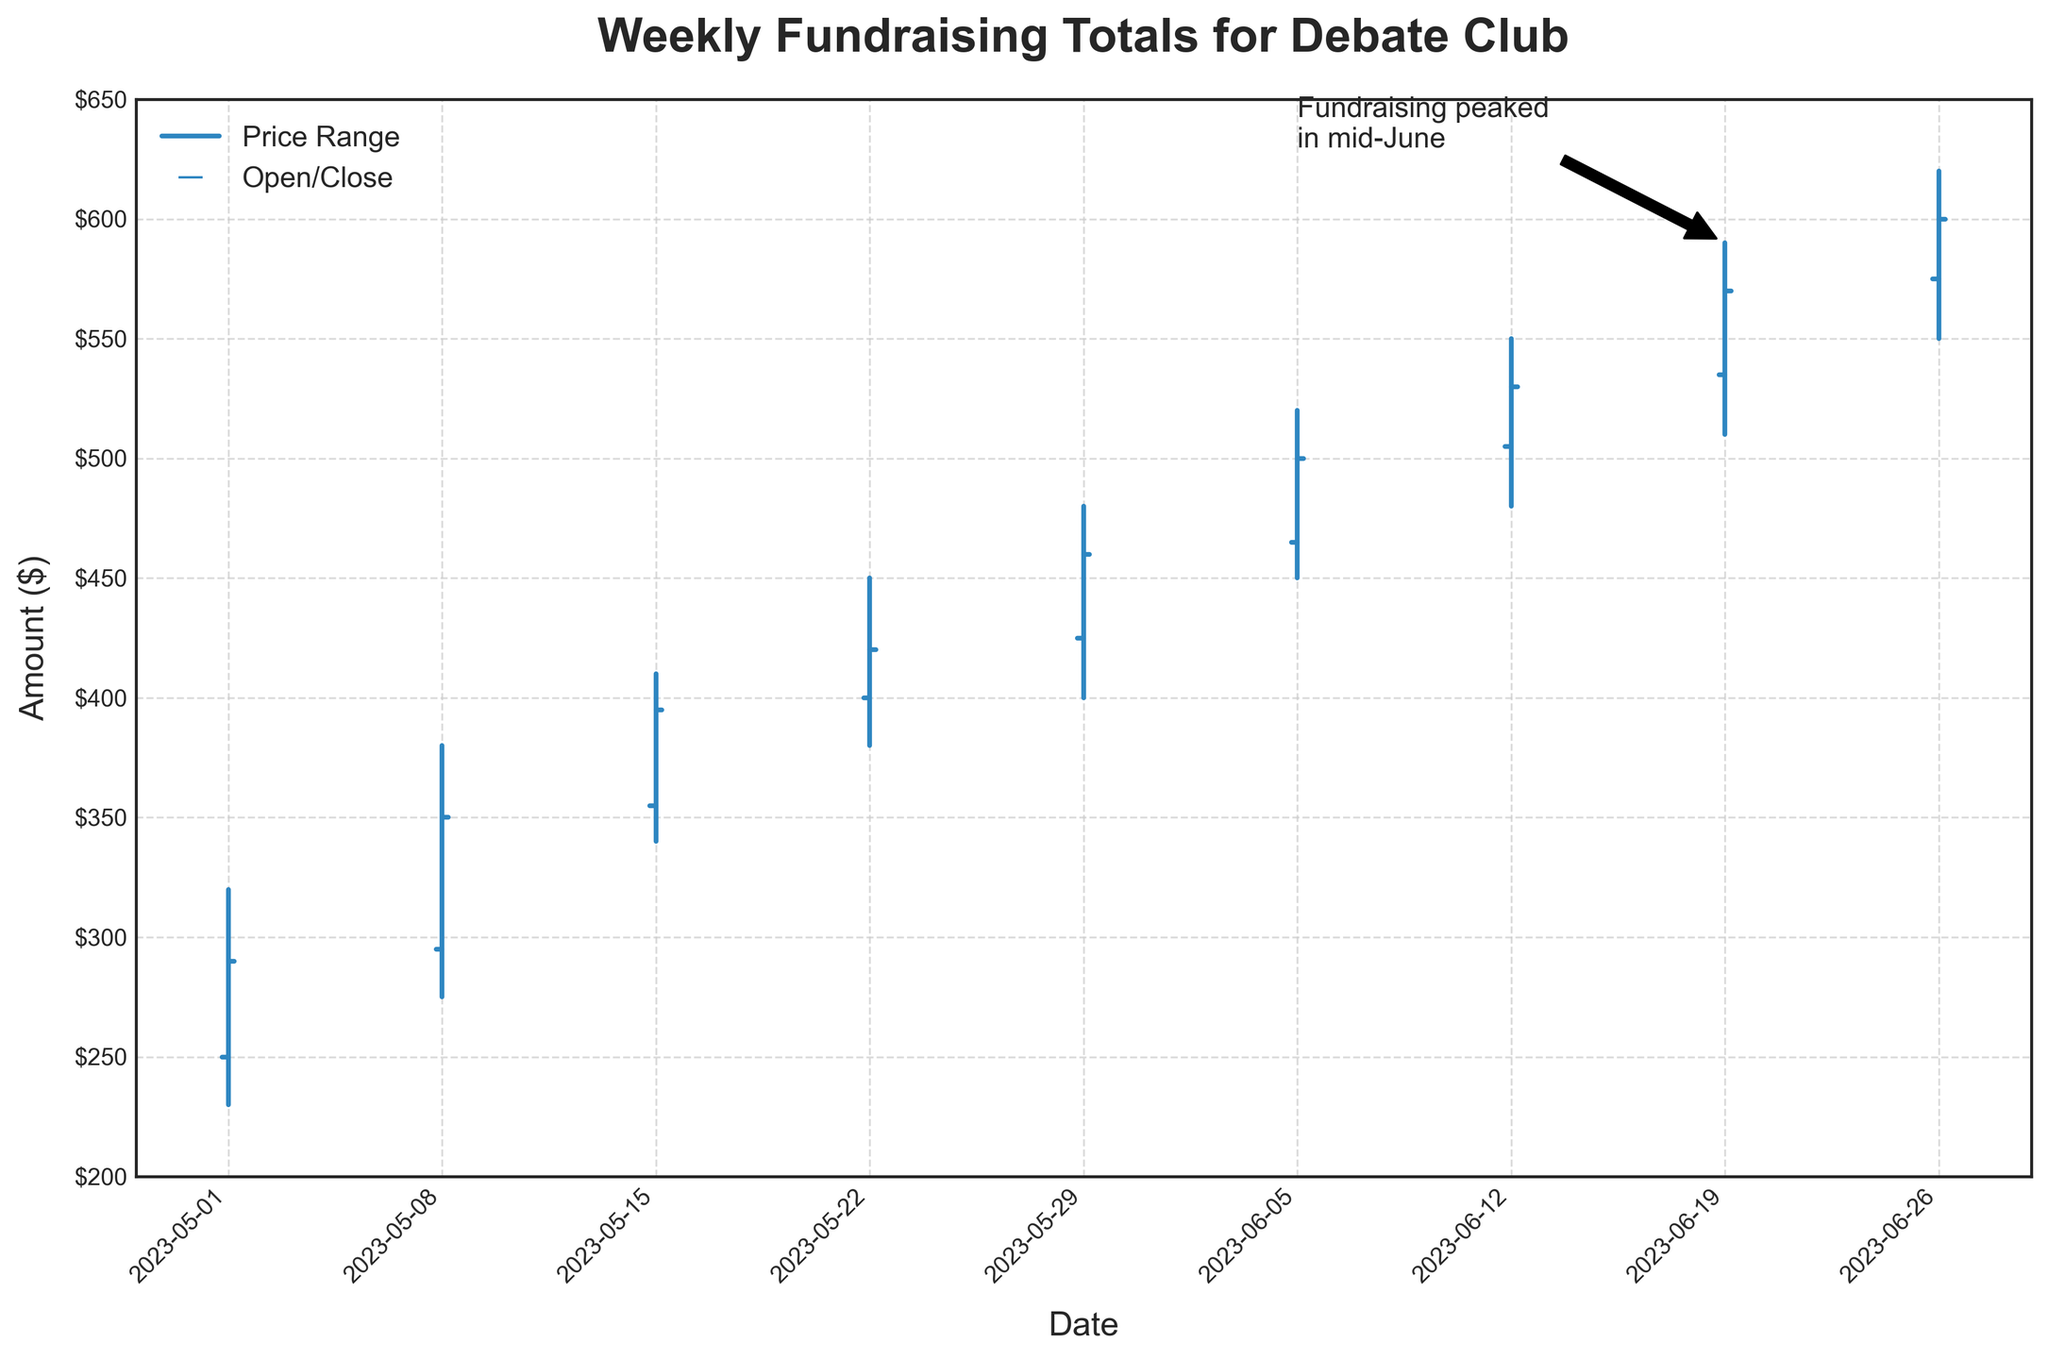What is the title of the figure? The title of the figure is prominently displayed at the top and usually indicates what the plot is about.
Answer: Weekly Fundraising Totals for Debate Club What is the date range displayed on the x-axis? By looking at the date labels on the x-axis, we can determine the date range covered in the figure.
Answer: May 1, 2023 to June 26, 2023 What is the closing amount for the week of May 22, 2023? Locate the date "May 22, 2023" on the x-axis, and then follow the horizontal line for the close value.
Answer: $420 Which week saw the largest total fundraising amount (highest closing value)? Compare the closing values of each week and identify the largest one.
Answer: June 26, 2023 What was the second-highest high value in the data? Compare the high values for each week and determine the second largest.
Answer: 590 How much did the opening amount increase from the week of May 1, 2023, to the week of May 8, 2023? Subtract the opening amount of May 1, 2023 from the opening amount of May 8, 2023: $295 - $250.
Answer: $45 What is the average high value for the month of June 2023? Sum the high values for each week in June (520 + 550 + 590 + 620) and divide by the number of weeks (4). (2280/4).
Answer: $570 Which weeks saw a fundraising increase, indicated by the close value being higher than the open value? Compare the open and close values for each week to see where close is greater than open.
Answer: All weeks Between which two consecutive weeks was there the largest increase in the closing amount? Calculate the difference in closing amounts for each pair of consecutive weeks and identify the largest difference.
Answer: June 19 to June 26 What does the annotation on the plot indicate? The annotation provides a specific note or highlight related to the visual data; here, it mentions the peak fundraising period.
Answer: Fundraising peaked in mid-June 